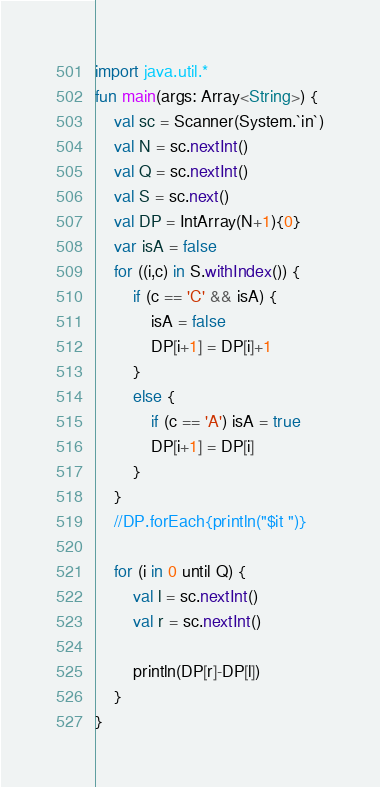<code> <loc_0><loc_0><loc_500><loc_500><_Kotlin_>import java.util.* 
fun main(args: Array<String>) {
    val sc = Scanner(System.`in`)
    val N = sc.nextInt()
    val Q = sc.nextInt()
    val S = sc.next()
    val DP = IntArray(N+1){0}
    var isA = false
    for ((i,c) in S.withIndex()) {
        if (c == 'C' && isA) {
            isA = false
            DP[i+1] = DP[i]+1
        }
        else {
            if (c == 'A') isA = true
            DP[i+1] = DP[i]
        }
    }
    //DP.forEach{println("$it ")}
    
    for (i in 0 until Q) {
        val l = sc.nextInt()
        val r = sc.nextInt()
    
        println(DP[r]-DP[l])
    }
}</code> 